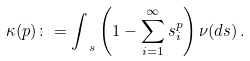<formula> <loc_0><loc_0><loc_500><loc_500>\kappa ( p ) \colon = \int _ { \ s } \left ( 1 - \sum _ { i = 1 } ^ { \infty } s _ { i } ^ { p } \right ) \nu ( d { s } ) \, .</formula> 